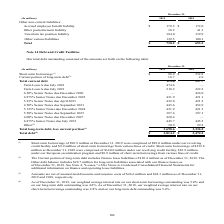According to Sealed Air Corporation's financial document, What were Short-term borrowings of $98.9 million at December 31, 2019 comprised of? $89.0 million under our revolving credit facility and $9.9 million of short-term borrowings from various lines of credit.. The document states: "8.9 million at December 31, 2019 were comprised of $89.0 million under our revolving credit facility and $9.9 million of short-term borrowings from va..." Also, What years are included for total debt outstanding? The document shows two values: 2019 and 2018. From the document: "(In millions) 2019 2018 (In millions) 2019 2018..." Also, What unit is used in the table? According to the financial document, millions. The relevant text states: "(In millions) 2019 2018..." Also, can you calculate: What is the total Term Loan A due as of December 31, 2019? Based on the calculation: 474.6+218.2, the result is 692.8 (in millions). This is based on the information: "Term Loan A due July 2023 218.2 222.2 Term Loan A due July 2022 474.6 —..." The key data points involved are: 218.2, 474.6. Also, can you calculate: What is the percentage of Total long-term debt, less current portion to Total debt as of December 31, 2019? Based on the calculation: 3,698.6/3,814.2, the result is 96.97 (percentage). This is based on the information: "Total debt (4) $ 3,814.2 $ 3,474.2 Total long-term debt, less current portion (3) 3,698.6 3,236.5..." The key data points involved are: 3,698.6, 3,814.2. Also, can you calculate: What is the percentage increase between the Total Debt as of 31 December, 2018 to as of 31 December, 2019?  To answer this question, I need to perform calculations using the financial data. The calculation is: (3,814.2-3,474.2)/3,474.2, which equals 9.79 (percentage). This is based on the information: "Total debt (4) $ 3,814.2 $ 3,474.2 Total debt (4) $ 3,814.2 $ 3,474.2..." The key data points involved are: 3,474.2, 3,814.2. 